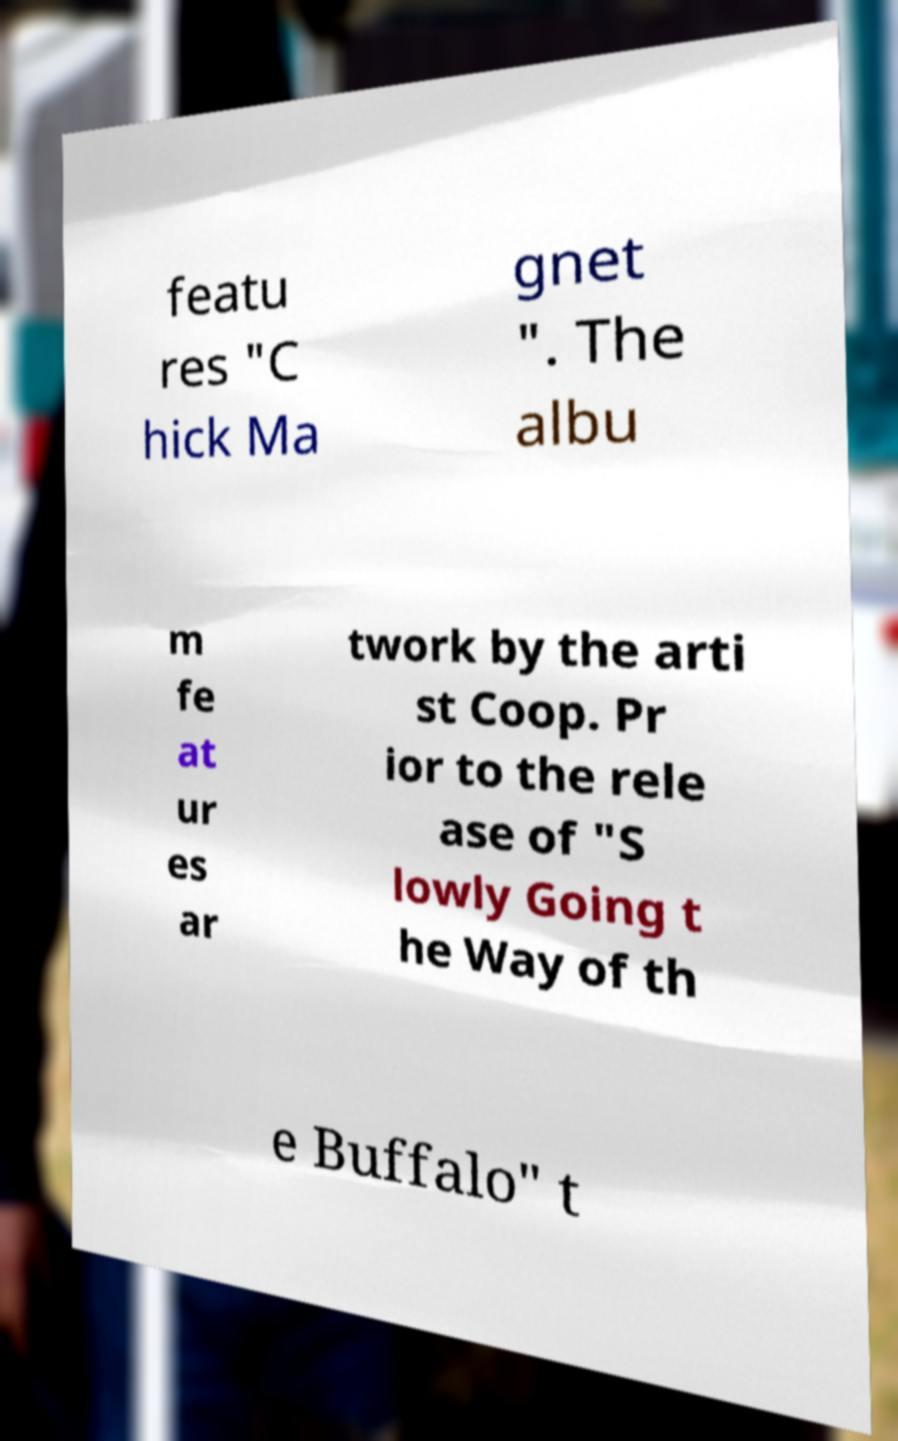I need the written content from this picture converted into text. Can you do that? featu res "C hick Ma gnet ". The albu m fe at ur es ar twork by the arti st Coop. Pr ior to the rele ase of "S lowly Going t he Way of th e Buffalo" t 